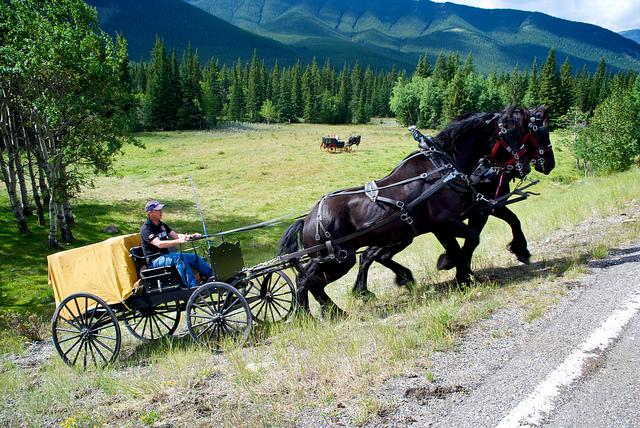What color is the man's hat?
Give a very brief answer. Blue. What is covering the wagon?
Concise answer only. Tarp. What is the man riding?
Write a very short answer. Wagon. 